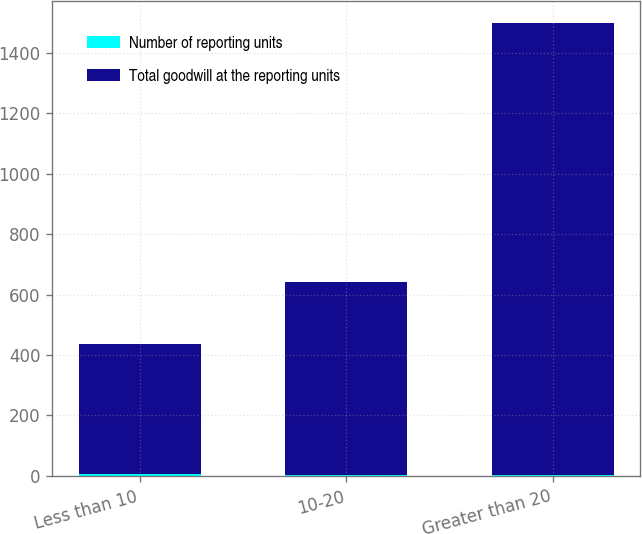Convert chart. <chart><loc_0><loc_0><loc_500><loc_500><stacked_bar_chart><ecel><fcel>Less than 10<fcel>10-20<fcel>Greater than 20<nl><fcel>Number of reporting units<fcel>5<fcel>4<fcel>4<nl><fcel>Total goodwill at the reporting units<fcel>430.4<fcel>638.6<fcel>1493.7<nl></chart> 